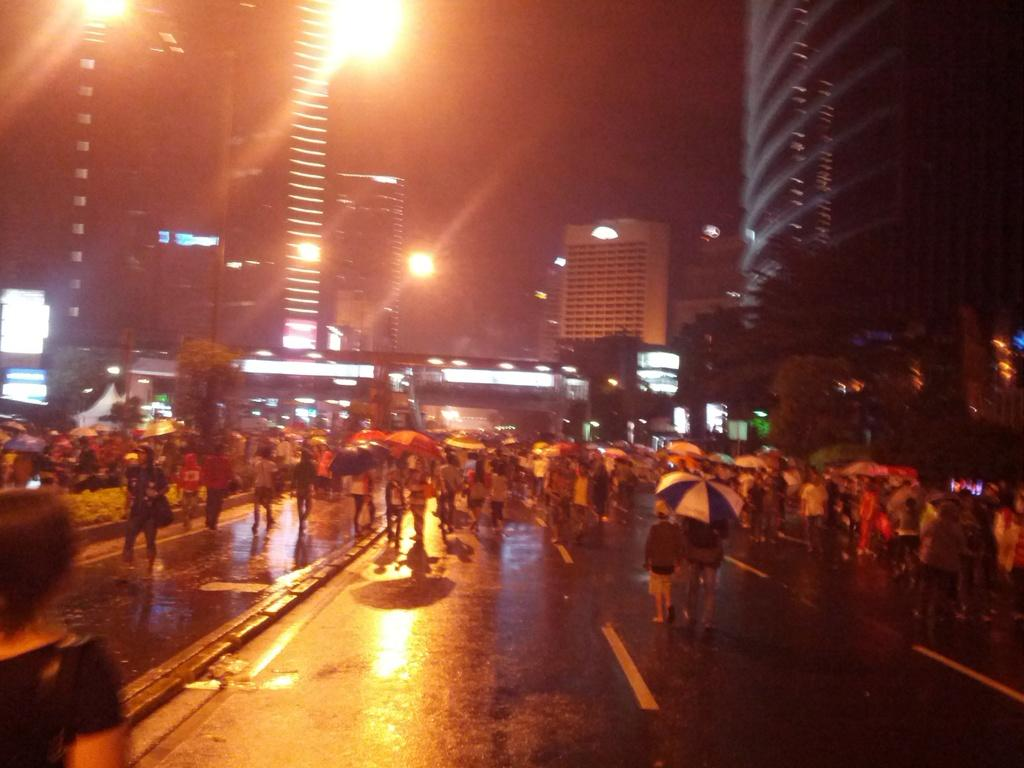What can be seen in the image involving multiple individuals? There are groups of people in the image. What are the people using to protect themselves from the weather? The people are holding umbrellas. What are the people doing in the image? The people are walking on the road. What type of structures can be seen in the image? There are buildings in the image. What type of illumination is present in the image? There are lights in the image. What type of vegetation is present in the image? There are trees in the image. How would you describe the overall lighting in the image? The background of the image is dark. How many tickets are visible in the image? There are no tickets present in the image. What type of grip does the sleet have on the trees in the image? There is no sleet present in the image, so it is not possible to determine its grip on the trees. 